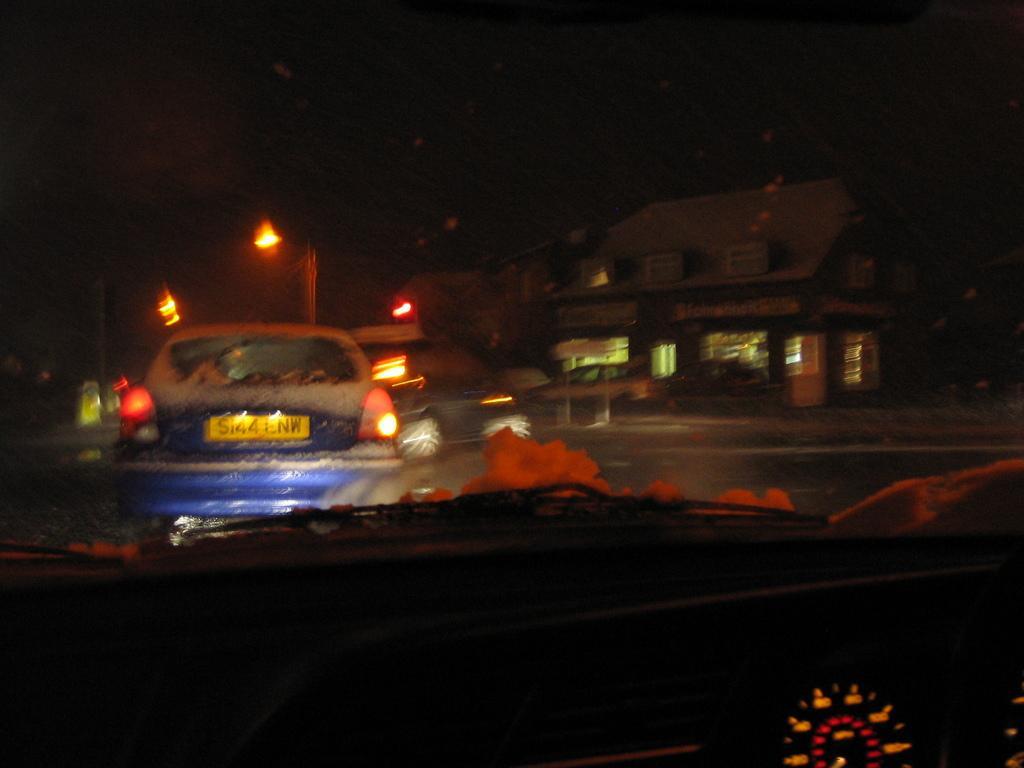In one or two sentences, can you explain what this image depicts? In this image we can see the speedometer. We can also see the vehicles passing on the road. Image also consists of lights, building and this image is taken during night time. 